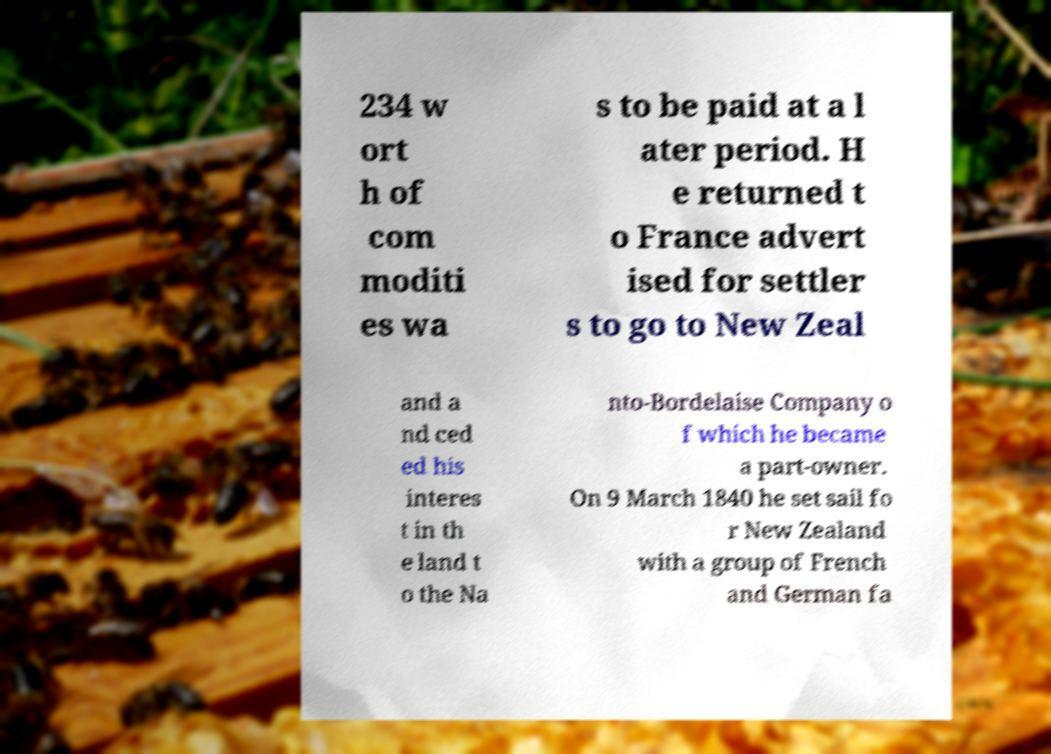Could you extract and type out the text from this image? 234 w ort h of com moditi es wa s to be paid at a l ater period. H e returned t o France advert ised for settler s to go to New Zeal and a nd ced ed his interes t in th e land t o the Na nto-Bordelaise Company o f which he became a part-owner. On 9 March 1840 he set sail fo r New Zealand with a group of French and German fa 